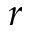<formula> <loc_0><loc_0><loc_500><loc_500>r</formula> 